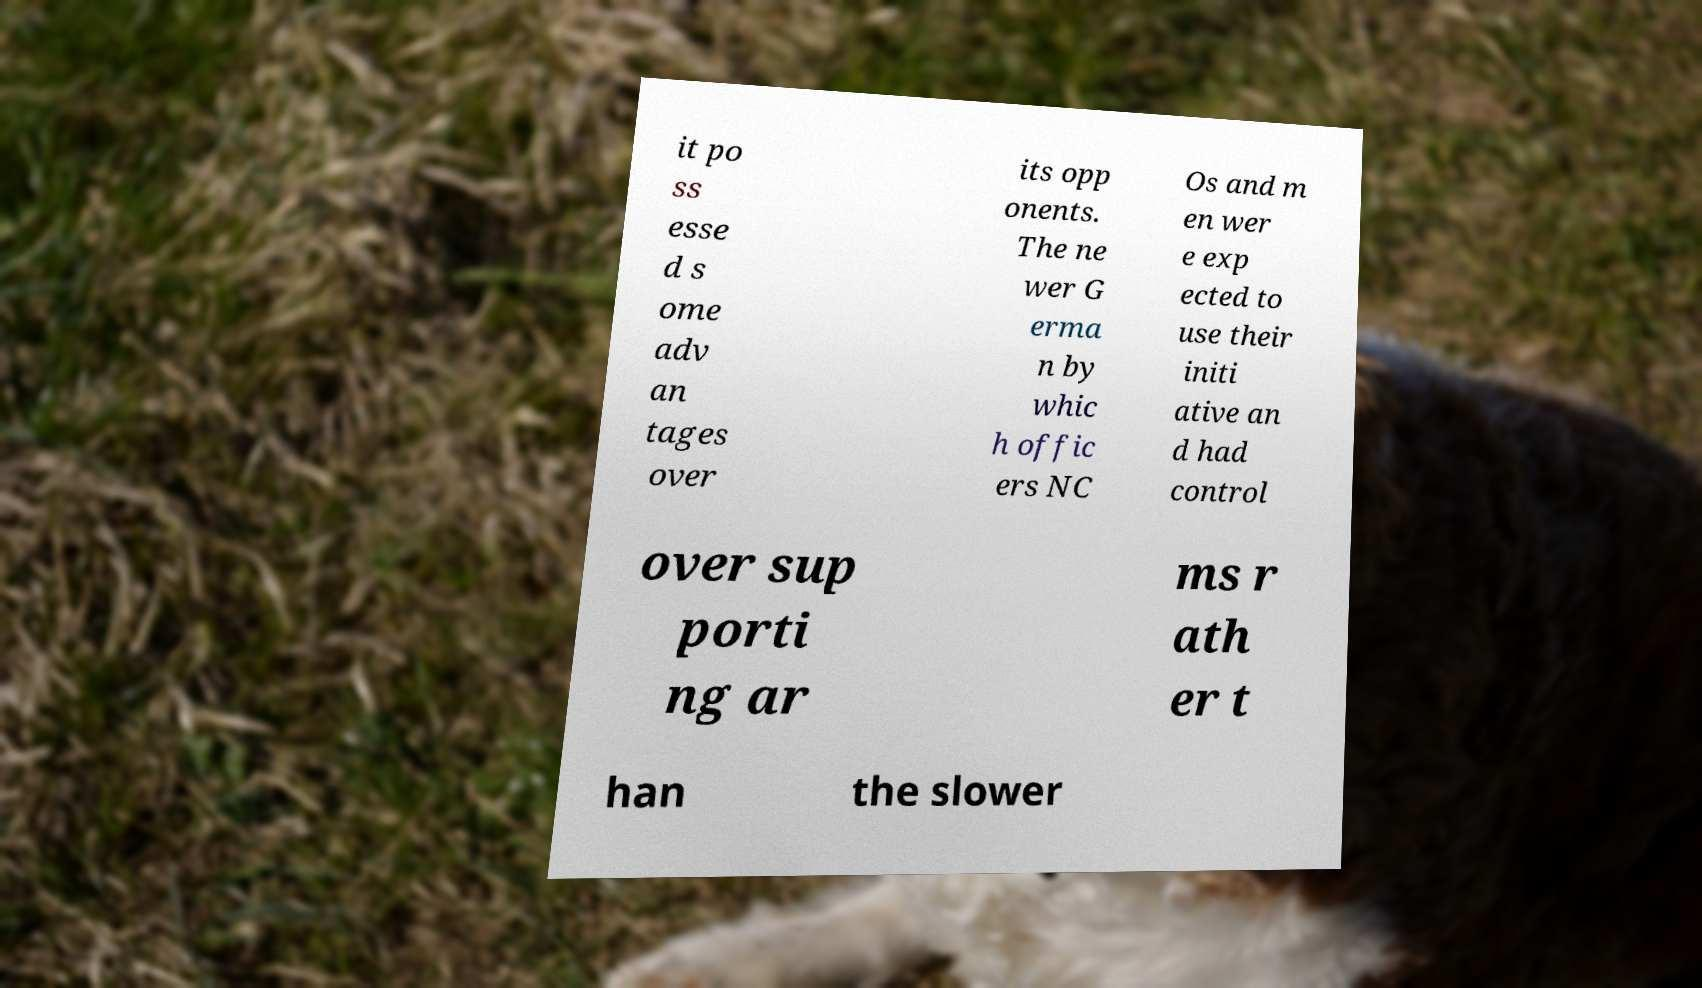Please identify and transcribe the text found in this image. it po ss esse d s ome adv an tages over its opp onents. The ne wer G erma n by whic h offic ers NC Os and m en wer e exp ected to use their initi ative an d had control over sup porti ng ar ms r ath er t han the slower 